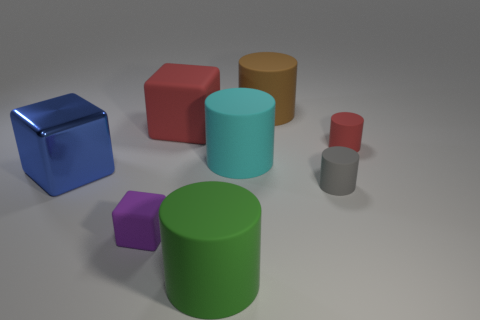Subtract all red cylinders. How many cylinders are left? 4 Subtract all red cylinders. How many cylinders are left? 4 Subtract all blue cylinders. Subtract all yellow spheres. How many cylinders are left? 5 Add 1 cyan cylinders. How many objects exist? 9 Subtract all cylinders. How many objects are left? 3 Add 4 big brown cylinders. How many big brown cylinders exist? 5 Subtract 0 cyan balls. How many objects are left? 8 Subtract all large green cylinders. Subtract all small blocks. How many objects are left? 6 Add 1 big blue things. How many big blue things are left? 2 